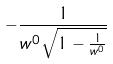Convert formula to latex. <formula><loc_0><loc_0><loc_500><loc_500>- \frac { 1 } { w ^ { 0 } \sqrt { 1 - \frac { 1 } { w ^ { 0 } } } }</formula> 